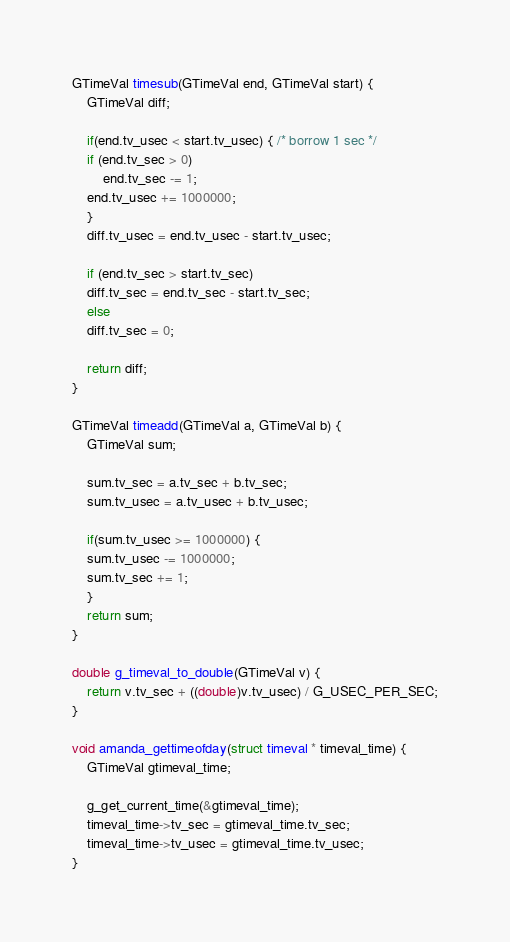Convert code to text. <code><loc_0><loc_0><loc_500><loc_500><_C_>GTimeVal timesub(GTimeVal end, GTimeVal start) {
    GTimeVal diff;

    if(end.tv_usec < start.tv_usec) { /* borrow 1 sec */
	if (end.tv_sec > 0)
	    end.tv_sec -= 1;
	end.tv_usec += 1000000;
    }
    diff.tv_usec = end.tv_usec - start.tv_usec;

    if (end.tv_sec > start.tv_sec)
	diff.tv_sec = end.tv_sec - start.tv_sec;
    else
	diff.tv_sec = 0;

    return diff;
}

GTimeVal timeadd(GTimeVal a, GTimeVal b) {
    GTimeVal sum;

    sum.tv_sec = a.tv_sec + b.tv_sec;
    sum.tv_usec = a.tv_usec + b.tv_usec;

    if(sum.tv_usec >= 1000000) {
	sum.tv_usec -= 1000000;
	sum.tv_sec += 1;
    }
    return sum;
}

double g_timeval_to_double(GTimeVal v) {
    return v.tv_sec + ((double)v.tv_usec) / G_USEC_PER_SEC;
}

void amanda_gettimeofday(struct timeval * timeval_time) {
    GTimeVal gtimeval_time;

    g_get_current_time(&gtimeval_time);
    timeval_time->tv_sec = gtimeval_time.tv_sec;
    timeval_time->tv_usec = gtimeval_time.tv_usec;
}
</code> 